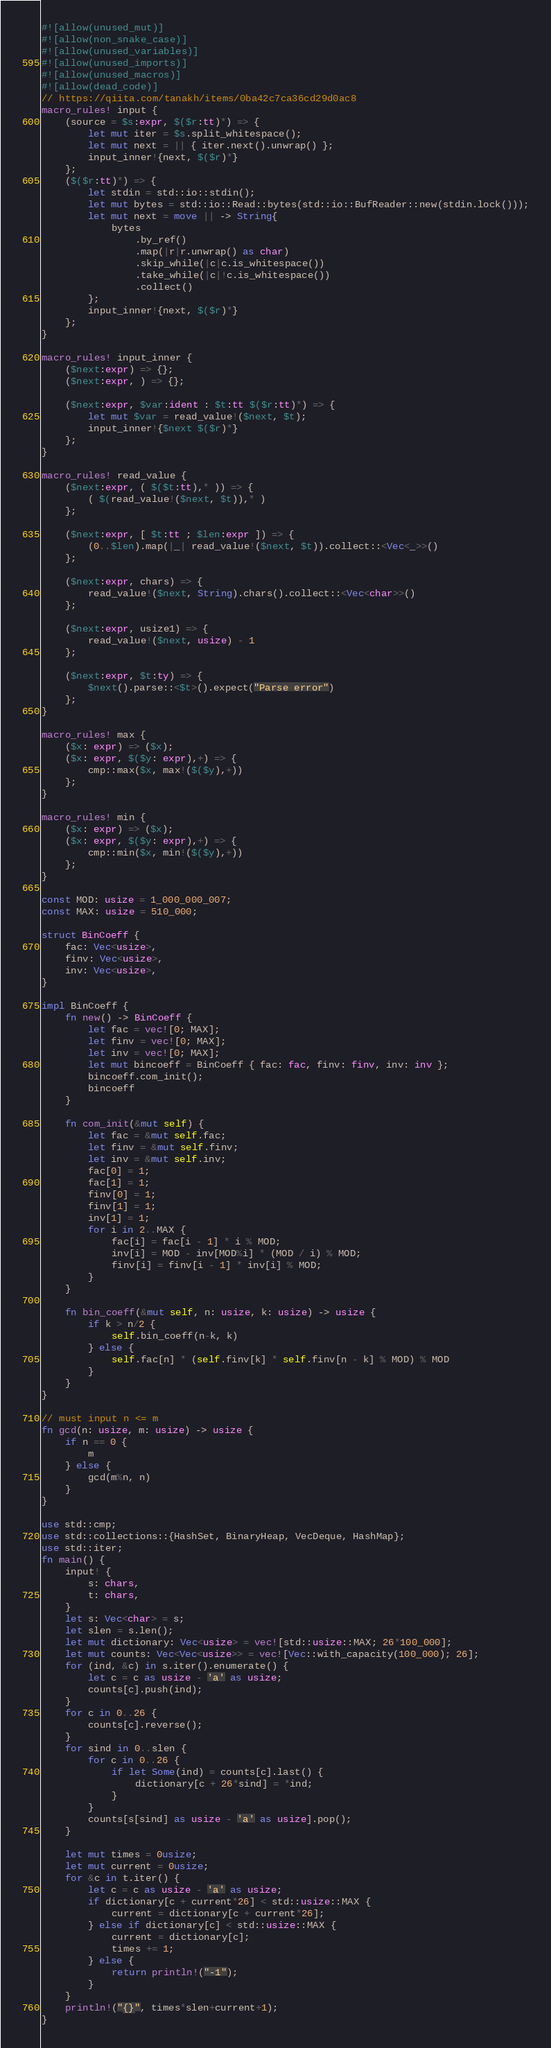<code> <loc_0><loc_0><loc_500><loc_500><_Rust_>#![allow(unused_mut)]
#![allow(non_snake_case)]
#![allow(unused_variables)]
#![allow(unused_imports)]
#![allow(unused_macros)]
#![allow(dead_code)]
// https://qiita.com/tanakh/items/0ba42c7ca36cd29d0ac8
macro_rules! input {
    (source = $s:expr, $($r:tt)*) => {
        let mut iter = $s.split_whitespace();
        let mut next = || { iter.next().unwrap() };
        input_inner!{next, $($r)*}
    };
    ($($r:tt)*) => {
        let stdin = std::io::stdin();
        let mut bytes = std::io::Read::bytes(std::io::BufReader::new(stdin.lock()));
        let mut next = move || -> String{
            bytes
                .by_ref()
                .map(|r|r.unwrap() as char)
                .skip_while(|c|c.is_whitespace())
                .take_while(|c|!c.is_whitespace())
                .collect()
        };
        input_inner!{next, $($r)*}
    };
}

macro_rules! input_inner {
    ($next:expr) => {};
    ($next:expr, ) => {};

    ($next:expr, $var:ident : $t:tt $($r:tt)*) => {
        let mut $var = read_value!($next, $t);
        input_inner!{$next $($r)*}
    };
}

macro_rules! read_value {
    ($next:expr, ( $($t:tt),* )) => {
        ( $(read_value!($next, $t)),* )
    };

    ($next:expr, [ $t:tt ; $len:expr ]) => {
        (0..$len).map(|_| read_value!($next, $t)).collect::<Vec<_>>()
    };

    ($next:expr, chars) => {
        read_value!($next, String).chars().collect::<Vec<char>>()
    };

    ($next:expr, usize1) => {
        read_value!($next, usize) - 1
    };

    ($next:expr, $t:ty) => {
        $next().parse::<$t>().expect("Parse error")
    };
}

macro_rules! max {
    ($x: expr) => ($x);
    ($x: expr, $($y: expr),+) => {
        cmp::max($x, max!($($y),+))
    };
}

macro_rules! min {
    ($x: expr) => ($x);
    ($x: expr, $($y: expr),+) => {
        cmp::min($x, min!($($y),+))
    };
}

const MOD: usize = 1_000_000_007;
const MAX: usize = 510_000;

struct BinCoeff {
    fac: Vec<usize>,
    finv: Vec<usize>,
    inv: Vec<usize>,
}

impl BinCoeff {
    fn new() -> BinCoeff {
        let fac = vec![0; MAX];
        let finv = vec![0; MAX];
        let inv = vec![0; MAX];
        let mut bincoeff = BinCoeff { fac: fac, finv: finv, inv: inv };
        bincoeff.com_init();
        bincoeff
    }

    fn com_init(&mut self) {
        let fac = &mut self.fac;
        let finv = &mut self.finv;
        let inv = &mut self.inv;
        fac[0] = 1;
        fac[1] = 1;
        finv[0] = 1;
        finv[1] = 1;
        inv[1] = 1;
        for i in 2..MAX {
            fac[i] = fac[i - 1] * i % MOD;
            inv[i] = MOD - inv[MOD%i] * (MOD / i) % MOD;
            finv[i] = finv[i - 1] * inv[i] % MOD;
        }
    }

    fn bin_coeff(&mut self, n: usize, k: usize) -> usize {
        if k > n/2 {
            self.bin_coeff(n-k, k)
        } else {
            self.fac[n] * (self.finv[k] * self.finv[n - k] % MOD) % MOD
        }
    }
}

// must input n <= m
fn gcd(n: usize, m: usize) -> usize {
    if n == 0 {
        m
    } else {
        gcd(m%n, n)
    }
}

use std::cmp;
use std::collections::{HashSet, BinaryHeap, VecDeque, HashMap};
use std::iter;
fn main() {
    input! {
        s: chars,
        t: chars,
    }
    let s: Vec<char> = s;
    let slen = s.len();
    let mut dictionary: Vec<usize> = vec![std::usize::MAX; 26*100_000];
    let mut counts: Vec<Vec<usize>> = vec![Vec::with_capacity(100_000); 26];
    for (ind, &c) in s.iter().enumerate() {
        let c = c as usize - 'a' as usize;
        counts[c].push(ind);
    }
    for c in 0..26 {
        counts[c].reverse();
    }
    for sind in 0..slen {
        for c in 0..26 {
            if let Some(ind) = counts[c].last() {
                dictionary[c + 26*sind] = *ind;
            }
        }
        counts[s[sind] as usize - 'a' as usize].pop();
    }

    let mut times = 0usize;
    let mut current = 0usize;
    for &c in t.iter() {
        let c = c as usize - 'a' as usize;
        if dictionary[c + current*26] < std::usize::MAX {
            current = dictionary[c + current*26];
        } else if dictionary[c] < std::usize::MAX {
            current = dictionary[c];
            times += 1;
        } else {
            return println!("-1");
        }
    }
    println!("{}", times*slen+current+1);
}</code> 